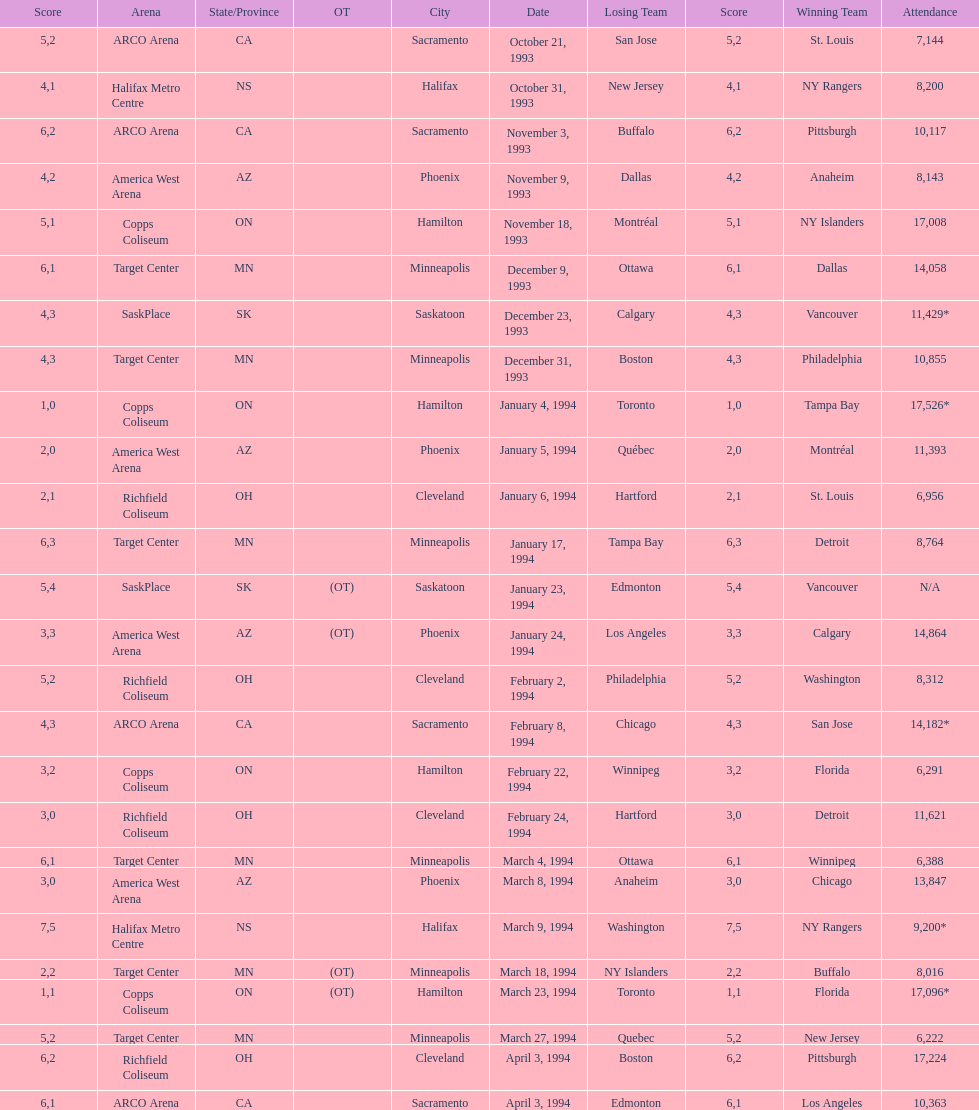How many neutral site games resulted in overtime (ot)? 4. 